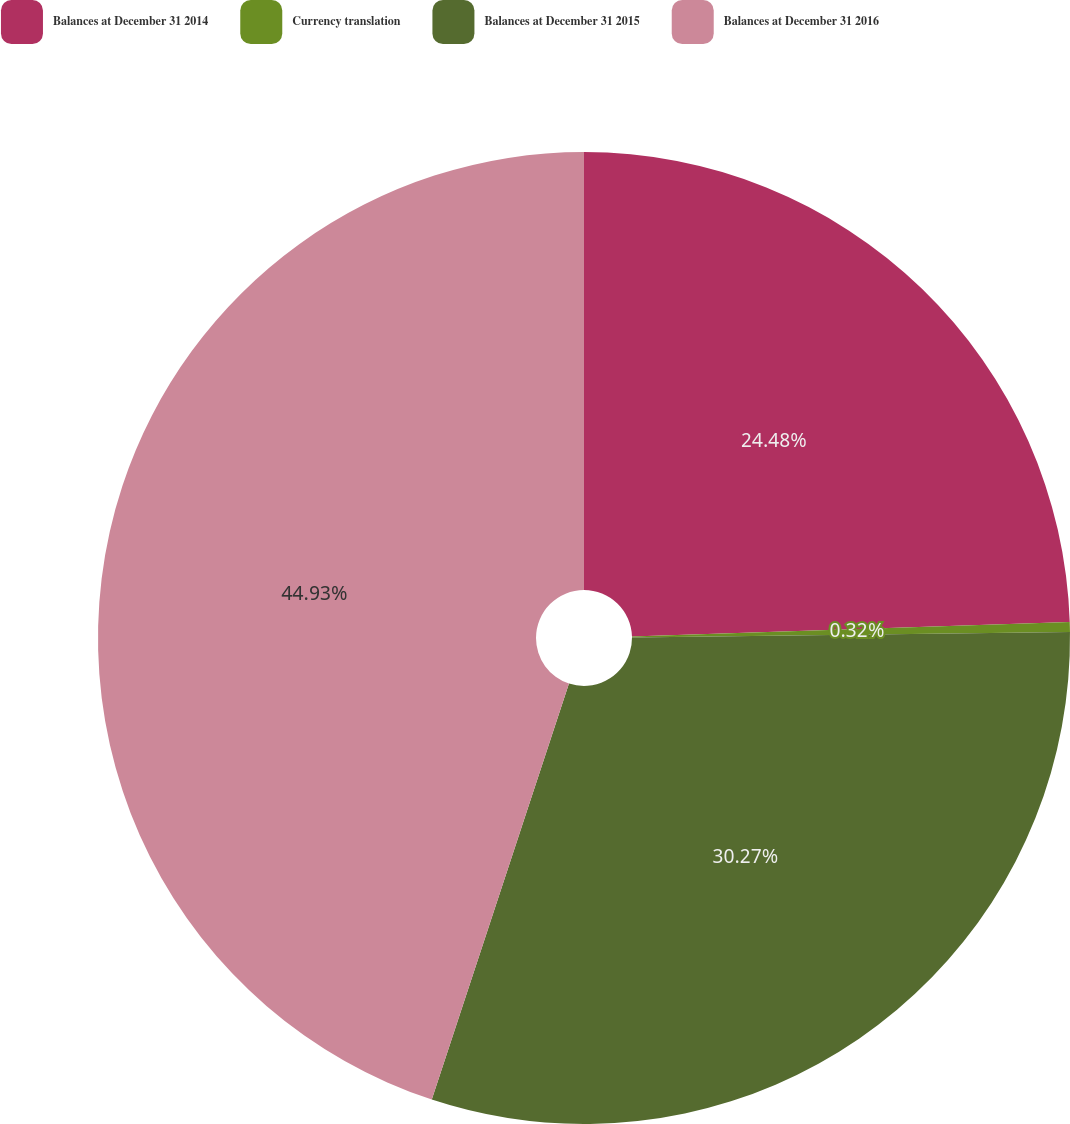Convert chart. <chart><loc_0><loc_0><loc_500><loc_500><pie_chart><fcel>Balances at December 31 2014<fcel>Currency translation<fcel>Balances at December 31 2015<fcel>Balances at December 31 2016<nl><fcel>24.48%<fcel>0.32%<fcel>30.27%<fcel>44.93%<nl></chart> 